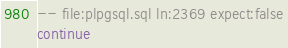Convert code to text. <code><loc_0><loc_0><loc_500><loc_500><_SQL_>-- file:plpgsql.sql ln:2369 expect:false
continue
</code> 